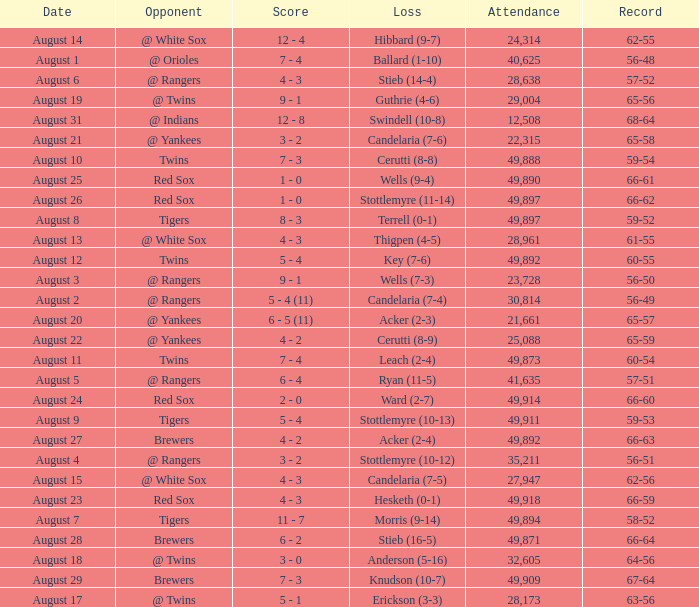What was the record of the game that had a loss of Stottlemyre (10-12)? 56-51. 